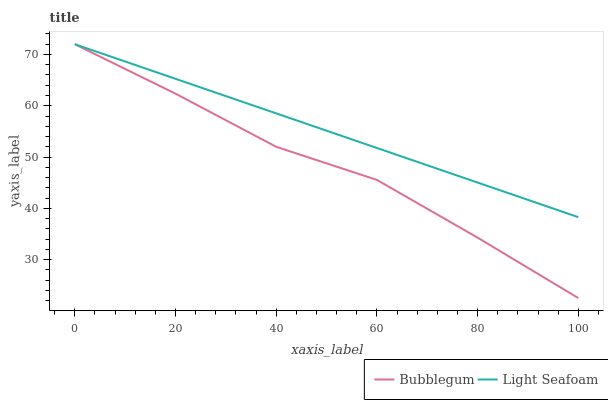Does Bubblegum have the minimum area under the curve?
Answer yes or no. Yes. Does Light Seafoam have the maximum area under the curve?
Answer yes or no. Yes. Does Bubblegum have the maximum area under the curve?
Answer yes or no. No. Is Light Seafoam the smoothest?
Answer yes or no. Yes. Is Bubblegum the roughest?
Answer yes or no. Yes. Is Bubblegum the smoothest?
Answer yes or no. No. Does Bubblegum have the lowest value?
Answer yes or no. Yes. Does Bubblegum have the highest value?
Answer yes or no. Yes. Does Light Seafoam intersect Bubblegum?
Answer yes or no. Yes. Is Light Seafoam less than Bubblegum?
Answer yes or no. No. Is Light Seafoam greater than Bubblegum?
Answer yes or no. No. 